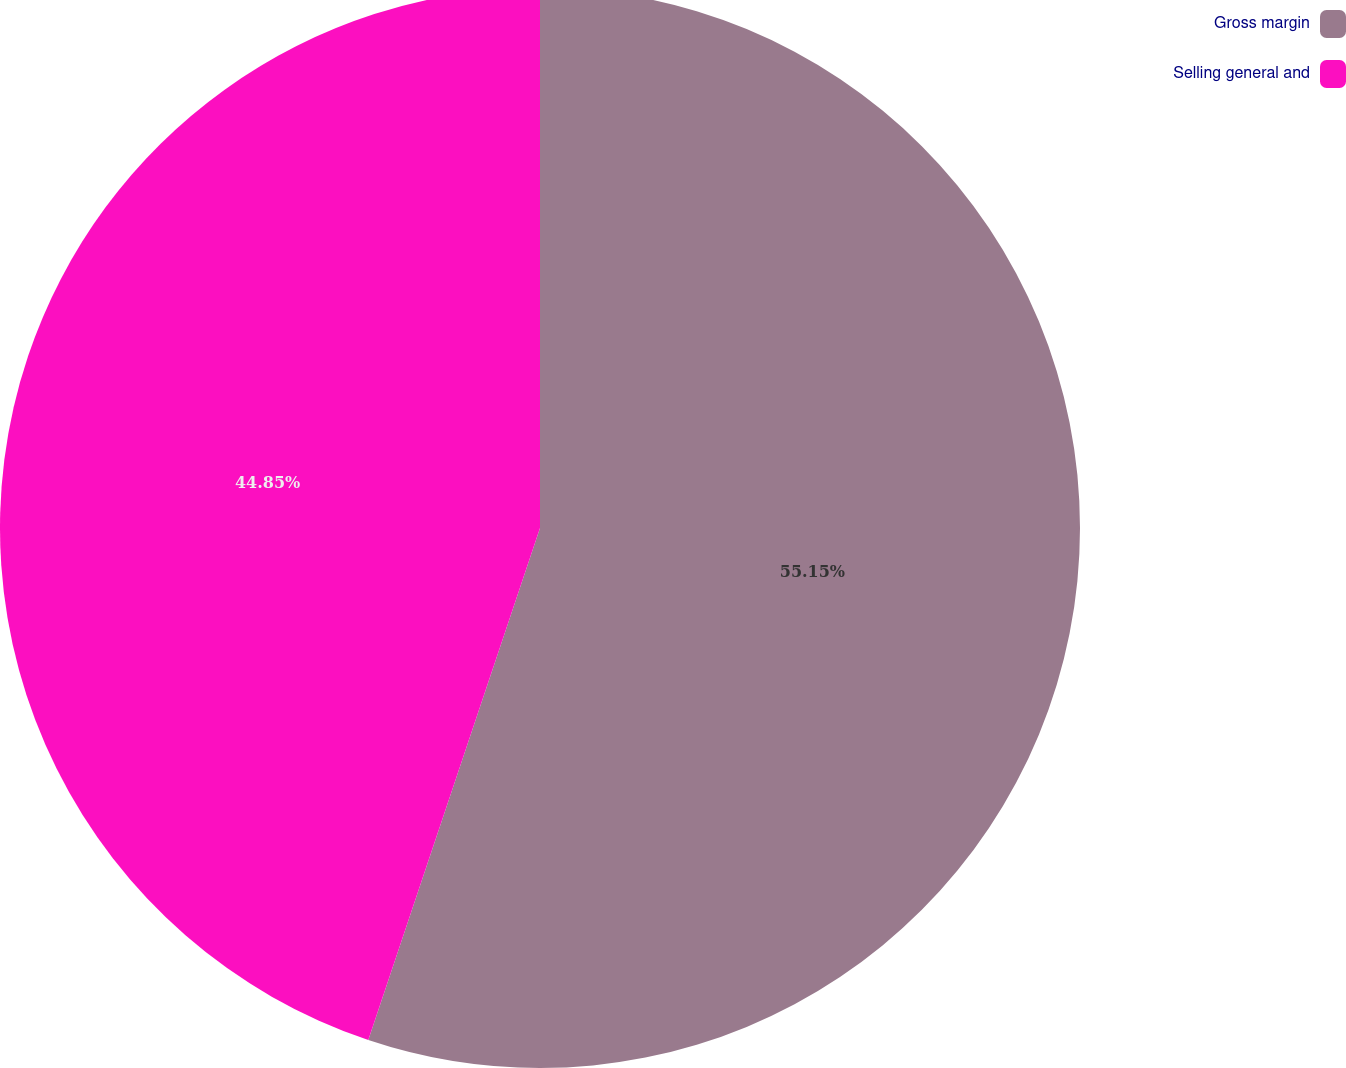<chart> <loc_0><loc_0><loc_500><loc_500><pie_chart><fcel>Gross margin<fcel>Selling general and<nl><fcel>55.15%<fcel>44.85%<nl></chart> 